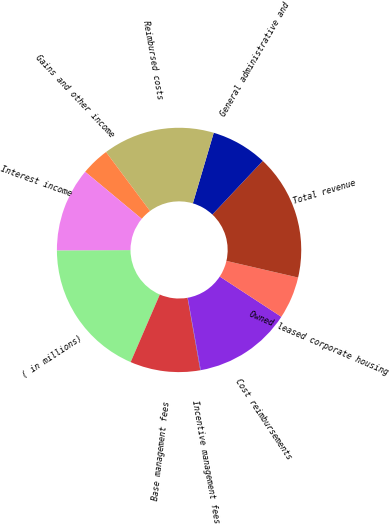<chart> <loc_0><loc_0><loc_500><loc_500><pie_chart><fcel>( in millions)<fcel>Base management fees<fcel>Incentive management fees<fcel>Cost reimbursements<fcel>Owned leased corporate housing<fcel>Total revenue<fcel>General administrative and<fcel>Reimbursed costs<fcel>Gains and other income<fcel>Interest income<nl><fcel>18.46%<fcel>9.26%<fcel>0.07%<fcel>12.94%<fcel>5.59%<fcel>16.62%<fcel>7.43%<fcel>14.78%<fcel>3.75%<fcel>11.1%<nl></chart> 